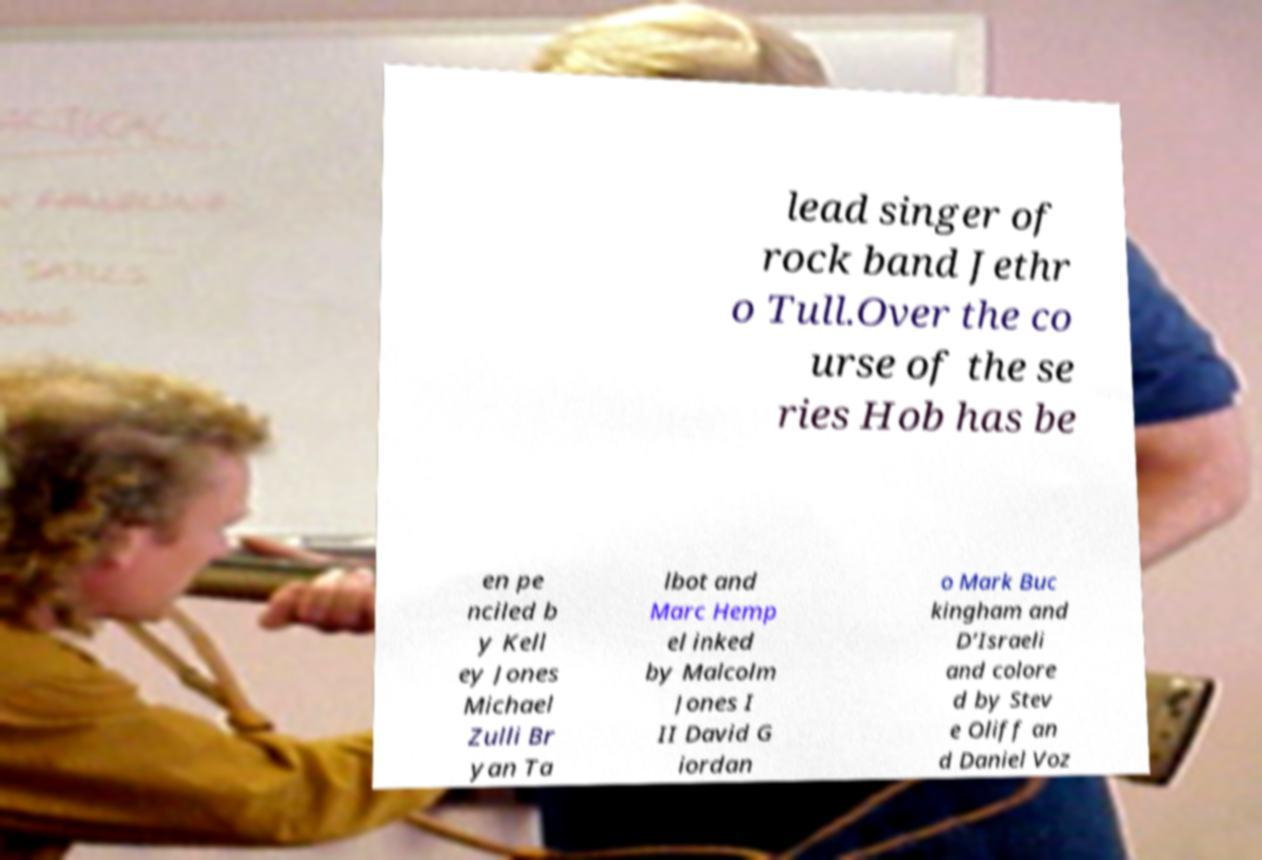For documentation purposes, I need the text within this image transcribed. Could you provide that? lead singer of rock band Jethr o Tull.Over the co urse of the se ries Hob has be en pe nciled b y Kell ey Jones Michael Zulli Br yan Ta lbot and Marc Hemp el inked by Malcolm Jones I II David G iordan o Mark Buc kingham and D’Israeli and colore d by Stev e Oliff an d Daniel Voz 